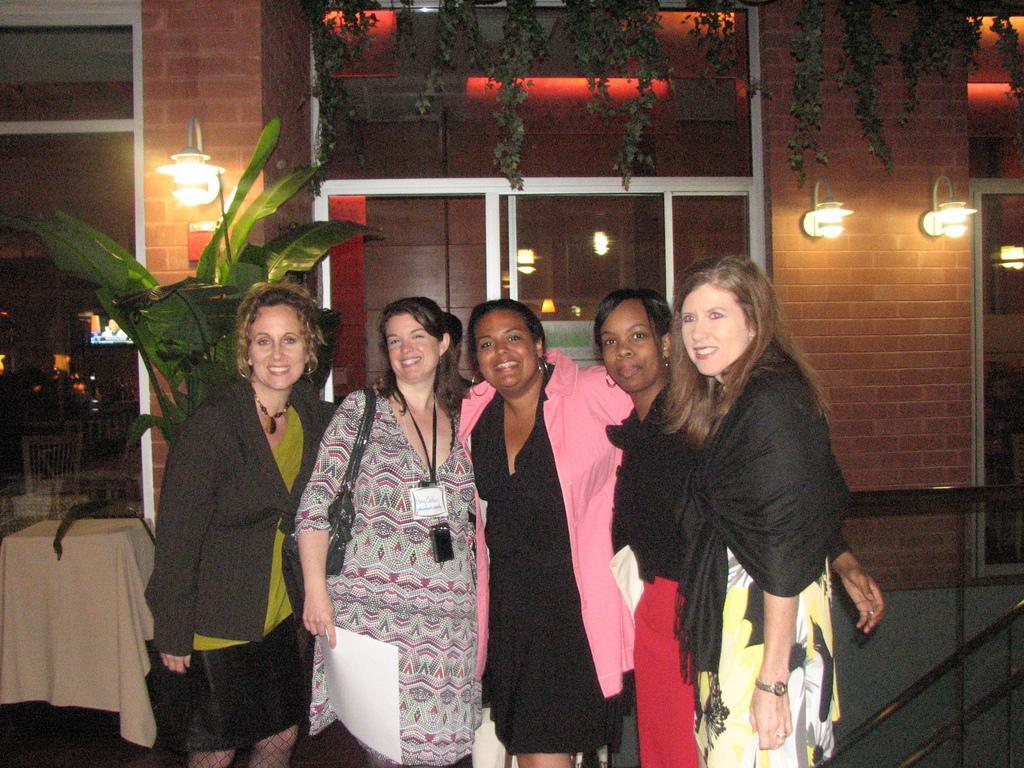In one or two sentences, can you explain what this image depicts? In this picture five persons are standing in the middle. All are smiling. There is a table and there is a cloth on that. This is the wall. These are the lights. And there is screen. Here this is the window. 